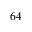Convert formula to latex. <formula><loc_0><loc_0><loc_500><loc_500>6 4</formula> 